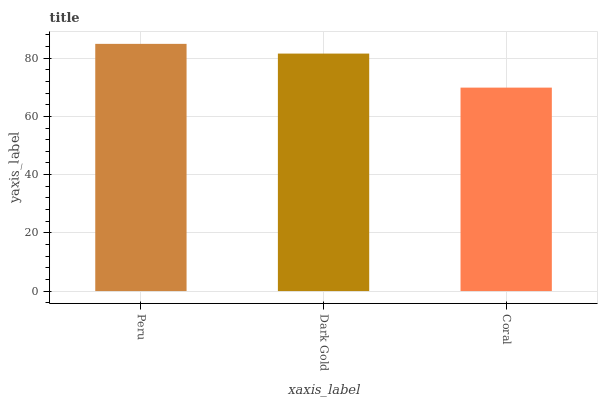Is Coral the minimum?
Answer yes or no. Yes. Is Peru the maximum?
Answer yes or no. Yes. Is Dark Gold the minimum?
Answer yes or no. No. Is Dark Gold the maximum?
Answer yes or no. No. Is Peru greater than Dark Gold?
Answer yes or no. Yes. Is Dark Gold less than Peru?
Answer yes or no. Yes. Is Dark Gold greater than Peru?
Answer yes or no. No. Is Peru less than Dark Gold?
Answer yes or no. No. Is Dark Gold the high median?
Answer yes or no. Yes. Is Dark Gold the low median?
Answer yes or no. Yes. Is Coral the high median?
Answer yes or no. No. Is Peru the low median?
Answer yes or no. No. 